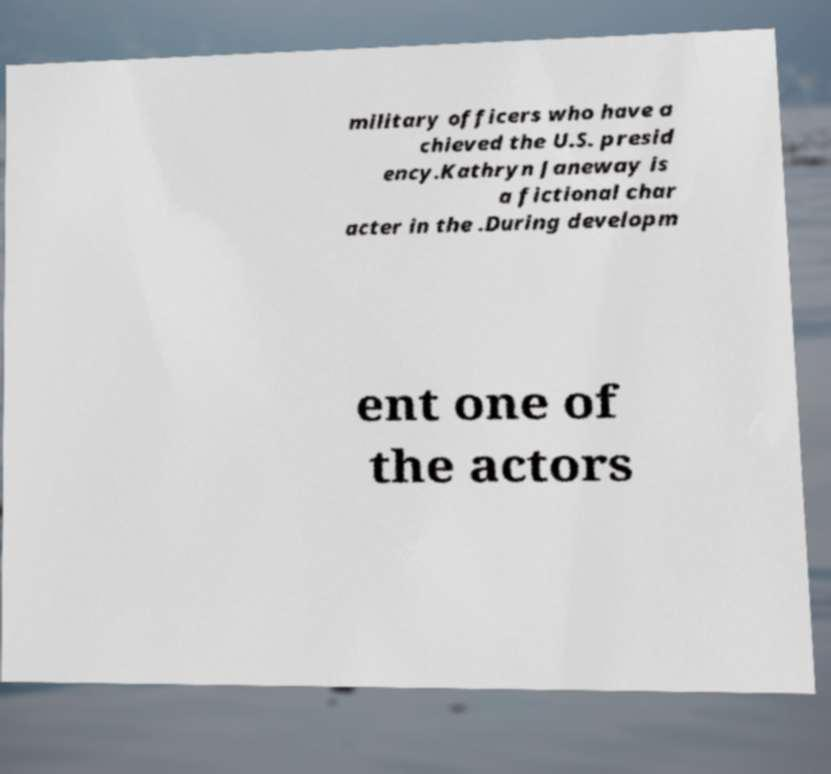Could you extract and type out the text from this image? military officers who have a chieved the U.S. presid ency.Kathryn Janeway is a fictional char acter in the .During developm ent one of the actors 